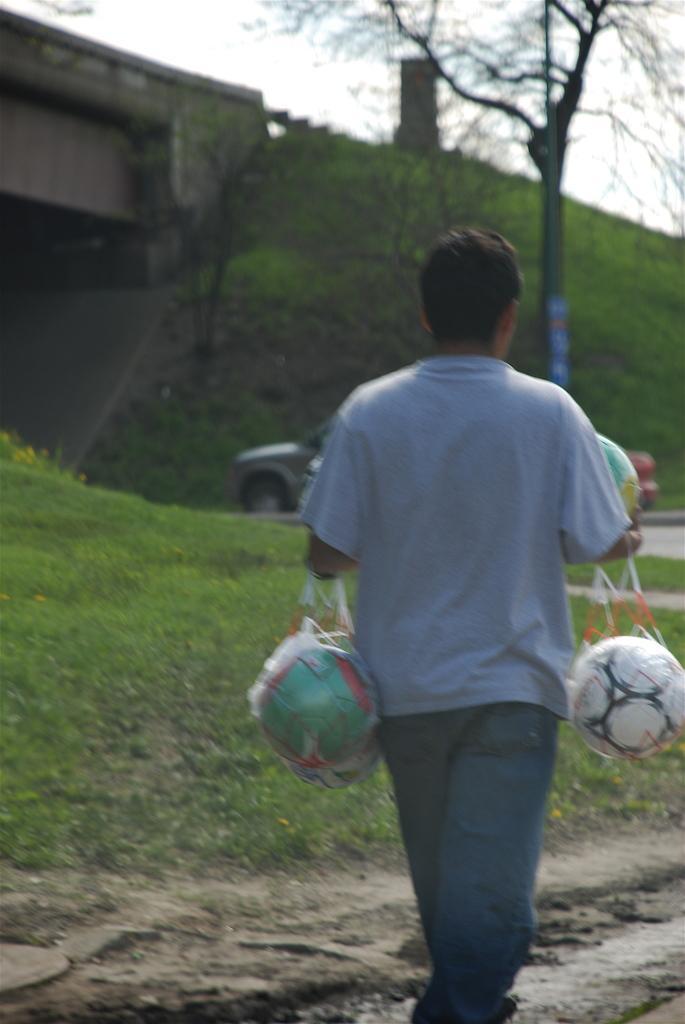How would you summarize this image in a sentence or two? This person walking and holding ball. We can see grass,bridge,tree,sky. 